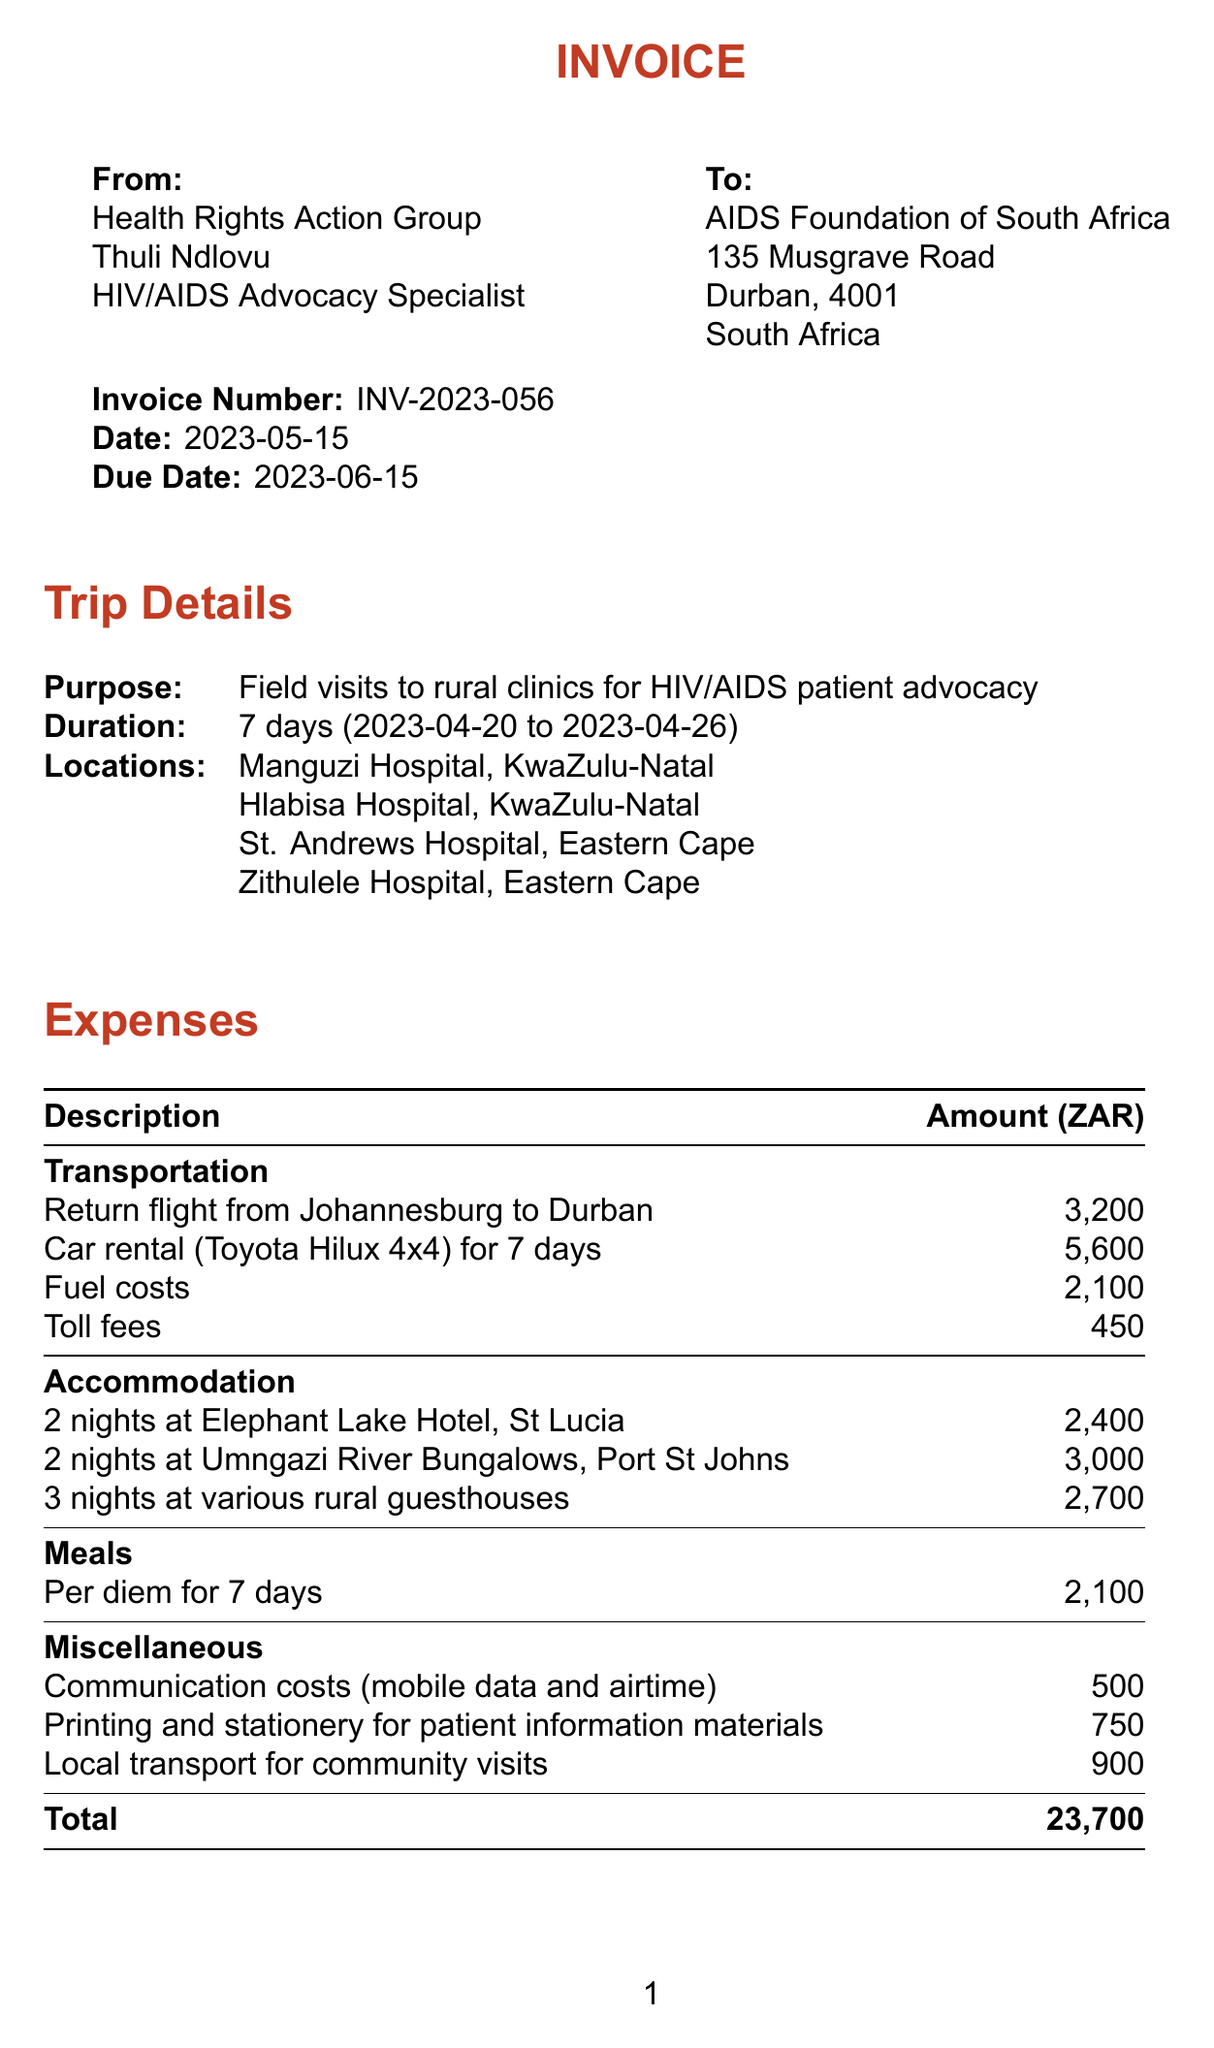what is the invoice number? The invoice number is explicitly stated in the invoice details section.
Answer: INV-2023-056 when was the invoice issued? The date of the invoice is clearly mentioned in the document.
Answer: 2023-05-15 who is the client? The client is specified in the invoice details.
Answer: AIDS Foundation of South Africa how many locations were visited during the trip? The number of locations visited can be counted from the trip details section.
Answer: 4 what is the total amount of expenses? The total amount is listed in the expenses section.
Answer: 23,700 what is the duration of the trip? The duration can be found in the trip details section.
Answer: 7 days which bank details are provided for payment? The payment details section lists the bank name.
Answer: Standard Bank what was the purpose of the trip? The purpose is outlined in the trip details section.
Answer: Field visits to rural clinics for HIV/AIDS patient advocacy how long is the payment due after the invoice date? The notes section states the payment timeline clearly.
Answer: 30 days 